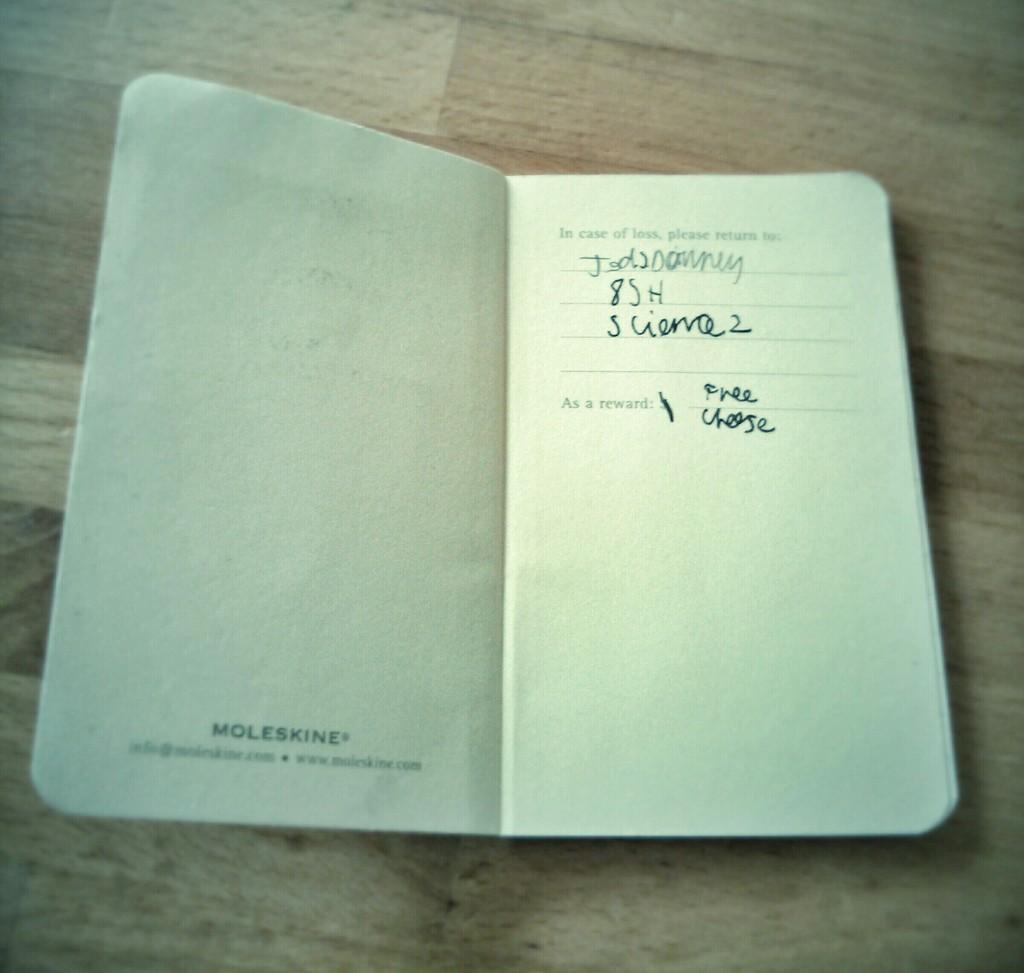What brand name is written on the left page?
Your response must be concise. Moleskine. 